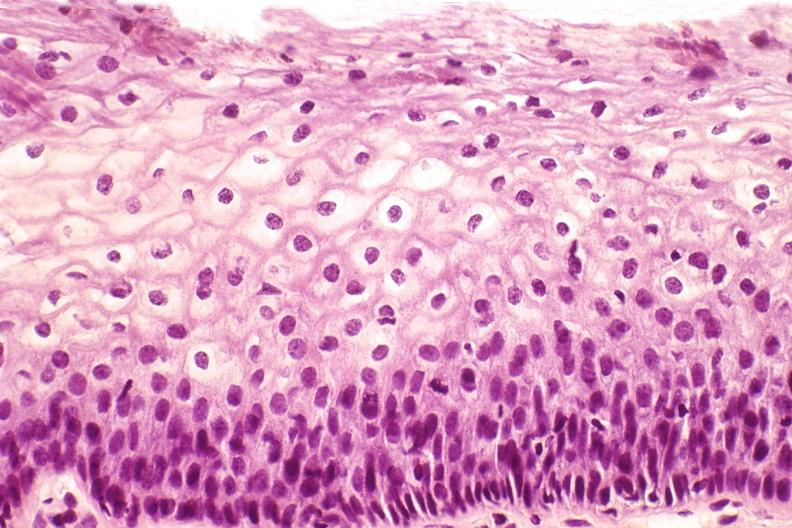s female reproductive present?
Answer the question using a single word or phrase. Yes 